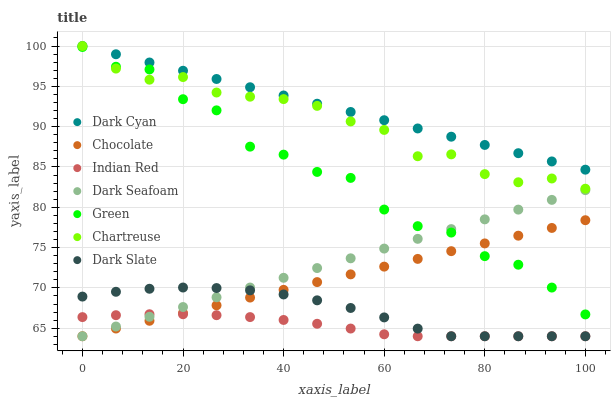Does Indian Red have the minimum area under the curve?
Answer yes or no. Yes. Does Dark Cyan have the maximum area under the curve?
Answer yes or no. Yes. Does Chocolate have the minimum area under the curve?
Answer yes or no. No. Does Chocolate have the maximum area under the curve?
Answer yes or no. No. Is Dark Cyan the smoothest?
Answer yes or no. Yes. Is Green the roughest?
Answer yes or no. Yes. Is Chocolate the smoothest?
Answer yes or no. No. Is Chocolate the roughest?
Answer yes or no. No. Does Chocolate have the lowest value?
Answer yes or no. Yes. Does Green have the lowest value?
Answer yes or no. No. Does Dark Cyan have the highest value?
Answer yes or no. Yes. Does Chocolate have the highest value?
Answer yes or no. No. Is Indian Red less than Dark Cyan?
Answer yes or no. Yes. Is Chartreuse greater than Chocolate?
Answer yes or no. Yes. Does Green intersect Dark Seafoam?
Answer yes or no. Yes. Is Green less than Dark Seafoam?
Answer yes or no. No. Is Green greater than Dark Seafoam?
Answer yes or no. No. Does Indian Red intersect Dark Cyan?
Answer yes or no. No. 